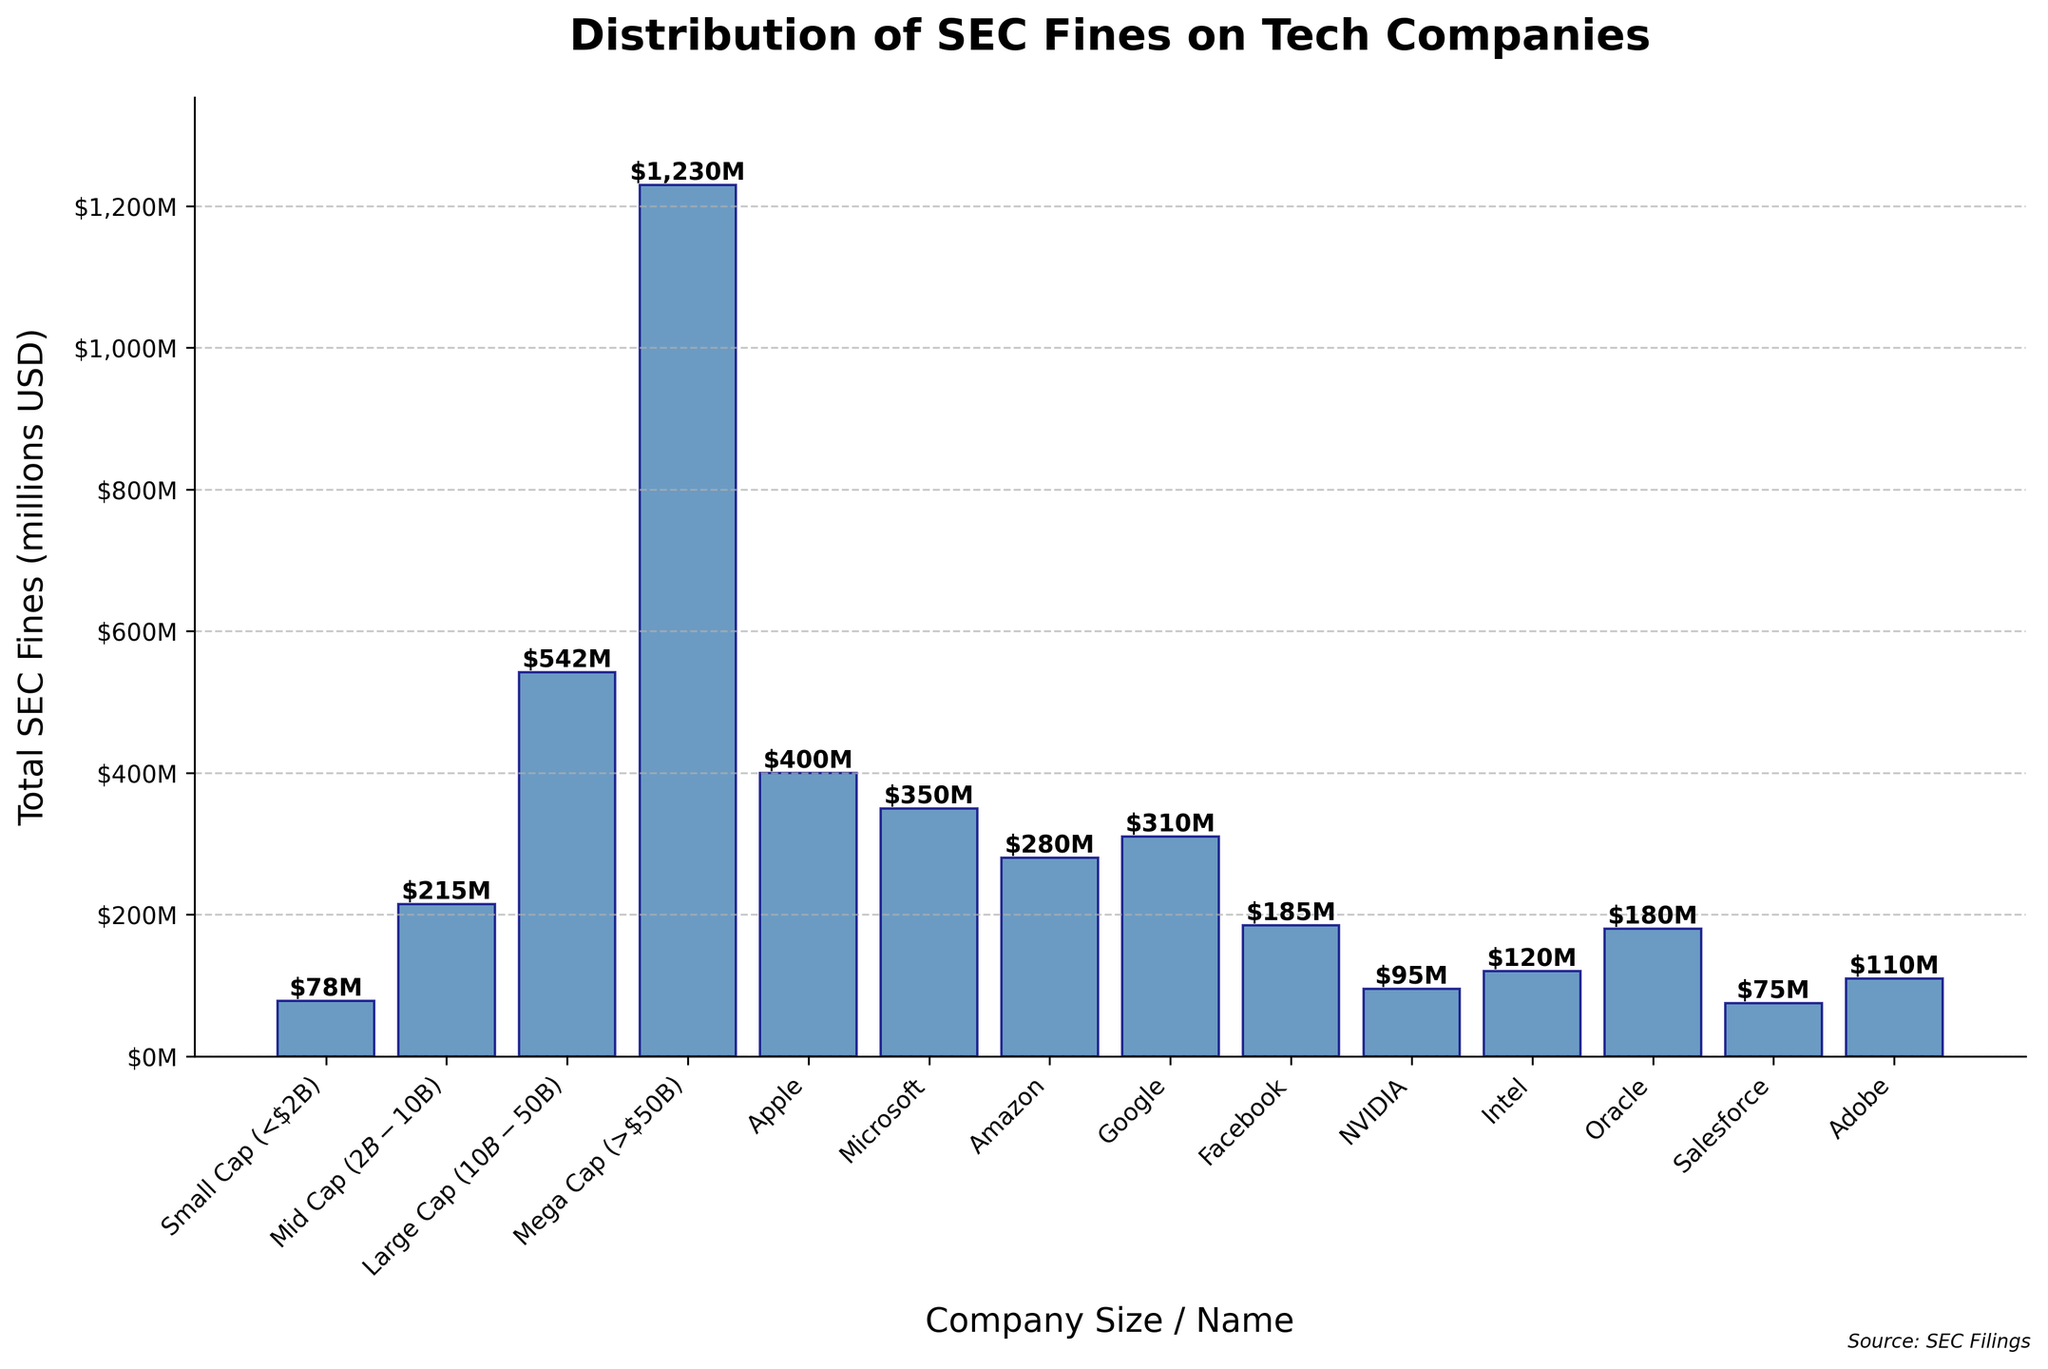Which company size category has the highest total SEC fines? The tallest bar represents the Mega Cap (>$50B) category. Observing the height of the bars, the Mega Cap category is the highest, suggesting it has the most fines.
Answer: Mega Cap (>$50B) How much are the total SEC fines for Large Cap ($10B-$50B) companies? The height of the bar for the Large Cap ($10B-$50B) category is at 542 million USD. This indicates that the total SEC fines for Large Cap companies are 542 million USD.
Answer: 542 million USD How do the SEC fines of Apple compare to those of Google? By comparing the heights of Apple's and Google's bars, it is observed that Apple’s bar is slightly higher than Google’s. Apple has 400 million USD, while Google has 310 million USD in fines.
Answer: Apple’s fines are higher Which company has the smallest total SEC fines among the individually listed companies, and what is the amount? Looking at the bars for individual companies, Salesforce (with a fine of 75 million USD) has the shortest bar.
Answer: Salesforce with 75 million USD What's the combined SEC fines for Microsoft and Amazon? Microsoft’s fines are 350 million USD, and Amazon’s are 280 million USD. Combining these values, 350 + 280 = 630 million USD.
Answer: 630 million USD How much more in fines does Mega Cap (>50B) companies have compared to Small Cap (<2B) companies? Mega Cap fines are 1,230 million USD, and Small Cap fines are 78 million USD. The difference is calculated as 1,230 - 78 = 1,152 million USD.
Answer: 1,152 million USD What is the average fine amount for the listed large tech companies (Apple, Microsoft, Amazon, Google, Facebook, NVIDIA, Intel, Oracle, Salesforce, Adobe)? Adding the fines of these companies: 400 + 350 + 280 + 310 + 185 + 95 + 120 + 180 + 75 + 110 = 2,105 million USD. There are 10 companies, so the average fine is 2,105 / 10 = 210.5 million USD.
Answer: 210.5 million USD Which is the second highest fined company among the individually listed companies? After Apple (400 million USD), Microsoft (350 million USD) has the next highest bar, indicating it is the second highest fined company.
Answer: Microsoft How do the total SEC fines for Small Cap companies compare to the individual fine for Apple? Small Cap companies have a total fine of 78 million USD, while Apple has a fine of 400 million USD. Apple's fines are significantly higher.
Answer: Apple’s fines are higher 